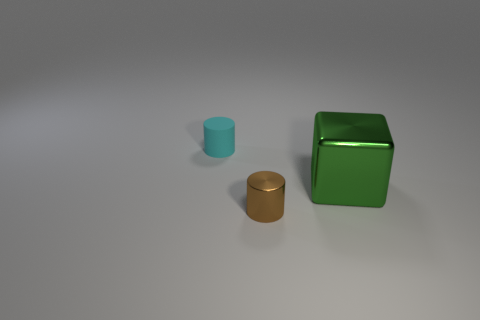Subtract all cylinders. How many objects are left? 1 Subtract 1 cubes. How many cubes are left? 0 Subtract all cyan cylinders. Subtract all cyan cubes. How many cylinders are left? 1 Subtract all red spheres. How many purple cylinders are left? 0 Subtract all small cyan things. Subtract all small brown metallic cylinders. How many objects are left? 1 Add 1 big green metal cubes. How many big green metal cubes are left? 2 Add 1 green cubes. How many green cubes exist? 2 Add 1 green metallic blocks. How many objects exist? 4 Subtract all cyan cylinders. How many cylinders are left? 1 Subtract 0 purple cylinders. How many objects are left? 3 